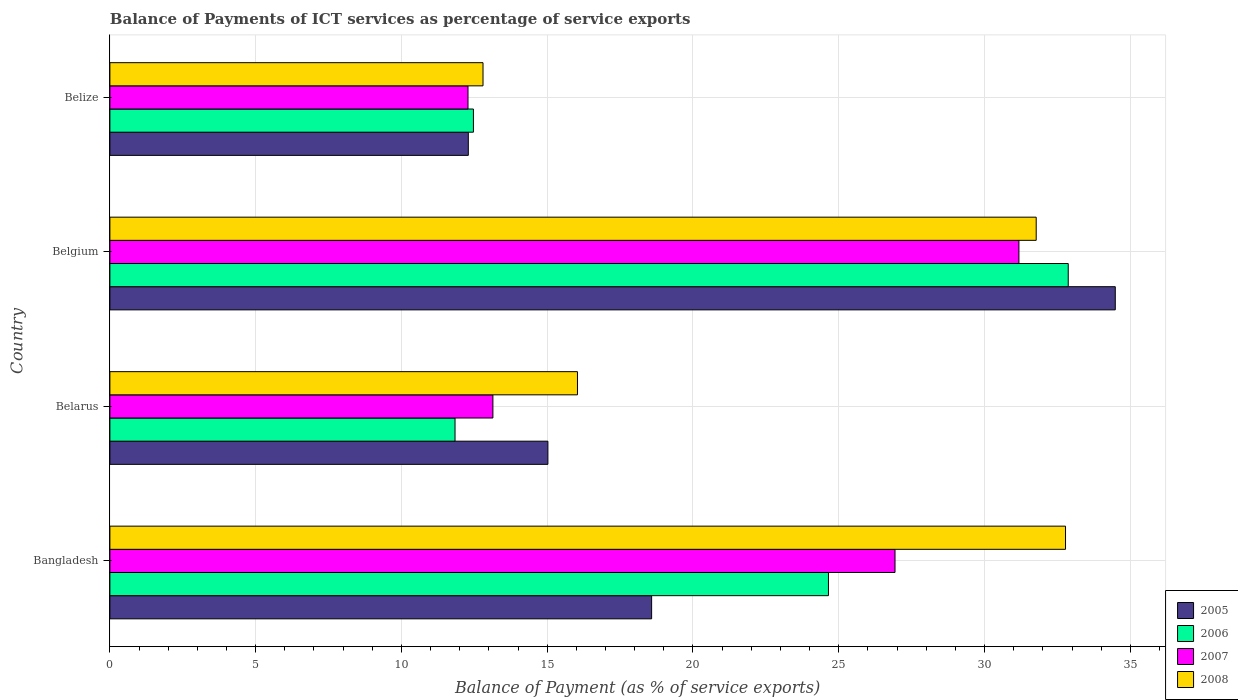How many bars are there on the 3rd tick from the top?
Your answer should be very brief. 4. What is the label of the 3rd group of bars from the top?
Offer a very short reply. Belarus. What is the balance of payments of ICT services in 2006 in Belgium?
Make the answer very short. 32.87. Across all countries, what is the maximum balance of payments of ICT services in 2008?
Keep it short and to the point. 32.78. Across all countries, what is the minimum balance of payments of ICT services in 2005?
Provide a succinct answer. 12.29. In which country was the balance of payments of ICT services in 2006 minimum?
Offer a terse response. Belarus. What is the total balance of payments of ICT services in 2006 in the graph?
Give a very brief answer. 81.83. What is the difference between the balance of payments of ICT services in 2007 in Belarus and that in Belize?
Provide a succinct answer. 0.85. What is the difference between the balance of payments of ICT services in 2005 in Bangladesh and the balance of payments of ICT services in 2008 in Belize?
Give a very brief answer. 5.78. What is the average balance of payments of ICT services in 2006 per country?
Offer a very short reply. 20.46. What is the difference between the balance of payments of ICT services in 2006 and balance of payments of ICT services in 2005 in Belarus?
Provide a succinct answer. -3.19. In how many countries, is the balance of payments of ICT services in 2007 greater than 23 %?
Provide a short and direct response. 2. What is the ratio of the balance of payments of ICT services in 2007 in Belgium to that in Belize?
Your answer should be compact. 2.54. Is the balance of payments of ICT services in 2008 in Bangladesh less than that in Belize?
Make the answer very short. No. Is the difference between the balance of payments of ICT services in 2006 in Belarus and Belgium greater than the difference between the balance of payments of ICT services in 2005 in Belarus and Belgium?
Make the answer very short. No. What is the difference between the highest and the second highest balance of payments of ICT services in 2007?
Your answer should be compact. 4.25. What is the difference between the highest and the lowest balance of payments of ICT services in 2008?
Keep it short and to the point. 19.98. Is it the case that in every country, the sum of the balance of payments of ICT services in 2005 and balance of payments of ICT services in 2008 is greater than the balance of payments of ICT services in 2007?
Your response must be concise. Yes. How many bars are there?
Make the answer very short. 16. Are the values on the major ticks of X-axis written in scientific E-notation?
Offer a very short reply. No. Does the graph contain any zero values?
Your answer should be compact. No. Where does the legend appear in the graph?
Your answer should be compact. Bottom right. How many legend labels are there?
Give a very brief answer. 4. What is the title of the graph?
Your answer should be compact. Balance of Payments of ICT services as percentage of service exports. Does "1966" appear as one of the legend labels in the graph?
Offer a very short reply. No. What is the label or title of the X-axis?
Make the answer very short. Balance of Payment (as % of service exports). What is the Balance of Payment (as % of service exports) of 2005 in Bangladesh?
Your response must be concise. 18.58. What is the Balance of Payment (as % of service exports) in 2006 in Bangladesh?
Your answer should be very brief. 24.65. What is the Balance of Payment (as % of service exports) in 2007 in Bangladesh?
Your answer should be very brief. 26.93. What is the Balance of Payment (as % of service exports) in 2008 in Bangladesh?
Ensure brevity in your answer.  32.78. What is the Balance of Payment (as % of service exports) in 2005 in Belarus?
Provide a succinct answer. 15.02. What is the Balance of Payment (as % of service exports) of 2006 in Belarus?
Your response must be concise. 11.84. What is the Balance of Payment (as % of service exports) of 2007 in Belarus?
Your answer should be very brief. 13.14. What is the Balance of Payment (as % of service exports) in 2008 in Belarus?
Ensure brevity in your answer.  16.04. What is the Balance of Payment (as % of service exports) in 2005 in Belgium?
Your response must be concise. 34.48. What is the Balance of Payment (as % of service exports) in 2006 in Belgium?
Offer a terse response. 32.87. What is the Balance of Payment (as % of service exports) of 2007 in Belgium?
Ensure brevity in your answer.  31.18. What is the Balance of Payment (as % of service exports) in 2008 in Belgium?
Provide a short and direct response. 31.77. What is the Balance of Payment (as % of service exports) of 2005 in Belize?
Your answer should be very brief. 12.29. What is the Balance of Payment (as % of service exports) in 2006 in Belize?
Provide a succinct answer. 12.47. What is the Balance of Payment (as % of service exports) in 2007 in Belize?
Ensure brevity in your answer.  12.28. What is the Balance of Payment (as % of service exports) of 2008 in Belize?
Your answer should be very brief. 12.8. Across all countries, what is the maximum Balance of Payment (as % of service exports) in 2005?
Ensure brevity in your answer.  34.48. Across all countries, what is the maximum Balance of Payment (as % of service exports) of 2006?
Give a very brief answer. 32.87. Across all countries, what is the maximum Balance of Payment (as % of service exports) in 2007?
Provide a succinct answer. 31.18. Across all countries, what is the maximum Balance of Payment (as % of service exports) in 2008?
Ensure brevity in your answer.  32.78. Across all countries, what is the minimum Balance of Payment (as % of service exports) of 2005?
Offer a terse response. 12.29. Across all countries, what is the minimum Balance of Payment (as % of service exports) in 2006?
Provide a short and direct response. 11.84. Across all countries, what is the minimum Balance of Payment (as % of service exports) of 2007?
Offer a terse response. 12.28. Across all countries, what is the minimum Balance of Payment (as % of service exports) of 2008?
Your answer should be very brief. 12.8. What is the total Balance of Payment (as % of service exports) of 2005 in the graph?
Give a very brief answer. 80.38. What is the total Balance of Payment (as % of service exports) of 2006 in the graph?
Your answer should be compact. 81.83. What is the total Balance of Payment (as % of service exports) of 2007 in the graph?
Your response must be concise. 83.53. What is the total Balance of Payment (as % of service exports) of 2008 in the graph?
Your answer should be compact. 93.39. What is the difference between the Balance of Payment (as % of service exports) of 2005 in Bangladesh and that in Belarus?
Make the answer very short. 3.56. What is the difference between the Balance of Payment (as % of service exports) in 2006 in Bangladesh and that in Belarus?
Offer a terse response. 12.81. What is the difference between the Balance of Payment (as % of service exports) in 2007 in Bangladesh and that in Belarus?
Offer a very short reply. 13.79. What is the difference between the Balance of Payment (as % of service exports) in 2008 in Bangladesh and that in Belarus?
Offer a very short reply. 16.74. What is the difference between the Balance of Payment (as % of service exports) in 2005 in Bangladesh and that in Belgium?
Your answer should be very brief. -15.9. What is the difference between the Balance of Payment (as % of service exports) of 2006 in Bangladesh and that in Belgium?
Your answer should be compact. -8.22. What is the difference between the Balance of Payment (as % of service exports) in 2007 in Bangladesh and that in Belgium?
Your response must be concise. -4.25. What is the difference between the Balance of Payment (as % of service exports) in 2008 in Bangladesh and that in Belgium?
Make the answer very short. 1.01. What is the difference between the Balance of Payment (as % of service exports) of 2005 in Bangladesh and that in Belize?
Provide a short and direct response. 6.29. What is the difference between the Balance of Payment (as % of service exports) of 2006 in Bangladesh and that in Belize?
Give a very brief answer. 12.18. What is the difference between the Balance of Payment (as % of service exports) in 2007 in Bangladesh and that in Belize?
Your answer should be compact. 14.65. What is the difference between the Balance of Payment (as % of service exports) in 2008 in Bangladesh and that in Belize?
Offer a terse response. 19.98. What is the difference between the Balance of Payment (as % of service exports) in 2005 in Belarus and that in Belgium?
Your response must be concise. -19.46. What is the difference between the Balance of Payment (as % of service exports) in 2006 in Belarus and that in Belgium?
Offer a terse response. -21.03. What is the difference between the Balance of Payment (as % of service exports) in 2007 in Belarus and that in Belgium?
Your response must be concise. -18.04. What is the difference between the Balance of Payment (as % of service exports) of 2008 in Belarus and that in Belgium?
Offer a terse response. -15.73. What is the difference between the Balance of Payment (as % of service exports) of 2005 in Belarus and that in Belize?
Your response must be concise. 2.73. What is the difference between the Balance of Payment (as % of service exports) of 2006 in Belarus and that in Belize?
Keep it short and to the point. -0.63. What is the difference between the Balance of Payment (as % of service exports) of 2007 in Belarus and that in Belize?
Keep it short and to the point. 0.85. What is the difference between the Balance of Payment (as % of service exports) in 2008 in Belarus and that in Belize?
Give a very brief answer. 3.24. What is the difference between the Balance of Payment (as % of service exports) in 2005 in Belgium and that in Belize?
Keep it short and to the point. 22.19. What is the difference between the Balance of Payment (as % of service exports) of 2006 in Belgium and that in Belize?
Provide a succinct answer. 20.4. What is the difference between the Balance of Payment (as % of service exports) of 2007 in Belgium and that in Belize?
Your response must be concise. 18.9. What is the difference between the Balance of Payment (as % of service exports) of 2008 in Belgium and that in Belize?
Give a very brief answer. 18.97. What is the difference between the Balance of Payment (as % of service exports) of 2005 in Bangladesh and the Balance of Payment (as % of service exports) of 2006 in Belarus?
Offer a very short reply. 6.74. What is the difference between the Balance of Payment (as % of service exports) of 2005 in Bangladesh and the Balance of Payment (as % of service exports) of 2007 in Belarus?
Provide a short and direct response. 5.44. What is the difference between the Balance of Payment (as % of service exports) of 2005 in Bangladesh and the Balance of Payment (as % of service exports) of 2008 in Belarus?
Give a very brief answer. 2.54. What is the difference between the Balance of Payment (as % of service exports) in 2006 in Bangladesh and the Balance of Payment (as % of service exports) in 2007 in Belarus?
Provide a short and direct response. 11.51. What is the difference between the Balance of Payment (as % of service exports) of 2006 in Bangladesh and the Balance of Payment (as % of service exports) of 2008 in Belarus?
Provide a succinct answer. 8.61. What is the difference between the Balance of Payment (as % of service exports) in 2007 in Bangladesh and the Balance of Payment (as % of service exports) in 2008 in Belarus?
Provide a succinct answer. 10.89. What is the difference between the Balance of Payment (as % of service exports) of 2005 in Bangladesh and the Balance of Payment (as % of service exports) of 2006 in Belgium?
Your answer should be very brief. -14.29. What is the difference between the Balance of Payment (as % of service exports) in 2005 in Bangladesh and the Balance of Payment (as % of service exports) in 2007 in Belgium?
Make the answer very short. -12.6. What is the difference between the Balance of Payment (as % of service exports) in 2005 in Bangladesh and the Balance of Payment (as % of service exports) in 2008 in Belgium?
Keep it short and to the point. -13.19. What is the difference between the Balance of Payment (as % of service exports) in 2006 in Bangladesh and the Balance of Payment (as % of service exports) in 2007 in Belgium?
Offer a very short reply. -6.53. What is the difference between the Balance of Payment (as % of service exports) of 2006 in Bangladesh and the Balance of Payment (as % of service exports) of 2008 in Belgium?
Your answer should be very brief. -7.13. What is the difference between the Balance of Payment (as % of service exports) in 2007 in Bangladesh and the Balance of Payment (as % of service exports) in 2008 in Belgium?
Your response must be concise. -4.84. What is the difference between the Balance of Payment (as % of service exports) of 2005 in Bangladesh and the Balance of Payment (as % of service exports) of 2006 in Belize?
Provide a succinct answer. 6.11. What is the difference between the Balance of Payment (as % of service exports) in 2005 in Bangladesh and the Balance of Payment (as % of service exports) in 2007 in Belize?
Offer a terse response. 6.3. What is the difference between the Balance of Payment (as % of service exports) of 2005 in Bangladesh and the Balance of Payment (as % of service exports) of 2008 in Belize?
Make the answer very short. 5.78. What is the difference between the Balance of Payment (as % of service exports) in 2006 in Bangladesh and the Balance of Payment (as % of service exports) in 2007 in Belize?
Offer a terse response. 12.36. What is the difference between the Balance of Payment (as % of service exports) in 2006 in Bangladesh and the Balance of Payment (as % of service exports) in 2008 in Belize?
Make the answer very short. 11.85. What is the difference between the Balance of Payment (as % of service exports) in 2007 in Bangladesh and the Balance of Payment (as % of service exports) in 2008 in Belize?
Keep it short and to the point. 14.13. What is the difference between the Balance of Payment (as % of service exports) of 2005 in Belarus and the Balance of Payment (as % of service exports) of 2006 in Belgium?
Your response must be concise. -17.85. What is the difference between the Balance of Payment (as % of service exports) of 2005 in Belarus and the Balance of Payment (as % of service exports) of 2007 in Belgium?
Your response must be concise. -16.16. What is the difference between the Balance of Payment (as % of service exports) of 2005 in Belarus and the Balance of Payment (as % of service exports) of 2008 in Belgium?
Ensure brevity in your answer.  -16.75. What is the difference between the Balance of Payment (as % of service exports) of 2006 in Belarus and the Balance of Payment (as % of service exports) of 2007 in Belgium?
Provide a short and direct response. -19.34. What is the difference between the Balance of Payment (as % of service exports) in 2006 in Belarus and the Balance of Payment (as % of service exports) in 2008 in Belgium?
Offer a very short reply. -19.93. What is the difference between the Balance of Payment (as % of service exports) of 2007 in Belarus and the Balance of Payment (as % of service exports) of 2008 in Belgium?
Offer a terse response. -18.64. What is the difference between the Balance of Payment (as % of service exports) of 2005 in Belarus and the Balance of Payment (as % of service exports) of 2006 in Belize?
Provide a short and direct response. 2.55. What is the difference between the Balance of Payment (as % of service exports) of 2005 in Belarus and the Balance of Payment (as % of service exports) of 2007 in Belize?
Provide a short and direct response. 2.74. What is the difference between the Balance of Payment (as % of service exports) of 2005 in Belarus and the Balance of Payment (as % of service exports) of 2008 in Belize?
Provide a succinct answer. 2.23. What is the difference between the Balance of Payment (as % of service exports) of 2006 in Belarus and the Balance of Payment (as % of service exports) of 2007 in Belize?
Ensure brevity in your answer.  -0.44. What is the difference between the Balance of Payment (as % of service exports) of 2006 in Belarus and the Balance of Payment (as % of service exports) of 2008 in Belize?
Offer a terse response. -0.96. What is the difference between the Balance of Payment (as % of service exports) in 2007 in Belarus and the Balance of Payment (as % of service exports) in 2008 in Belize?
Your answer should be compact. 0.34. What is the difference between the Balance of Payment (as % of service exports) of 2005 in Belgium and the Balance of Payment (as % of service exports) of 2006 in Belize?
Provide a short and direct response. 22.02. What is the difference between the Balance of Payment (as % of service exports) in 2005 in Belgium and the Balance of Payment (as % of service exports) in 2007 in Belize?
Provide a short and direct response. 22.2. What is the difference between the Balance of Payment (as % of service exports) in 2005 in Belgium and the Balance of Payment (as % of service exports) in 2008 in Belize?
Give a very brief answer. 21.69. What is the difference between the Balance of Payment (as % of service exports) of 2006 in Belgium and the Balance of Payment (as % of service exports) of 2007 in Belize?
Provide a succinct answer. 20.59. What is the difference between the Balance of Payment (as % of service exports) in 2006 in Belgium and the Balance of Payment (as % of service exports) in 2008 in Belize?
Provide a succinct answer. 20.07. What is the difference between the Balance of Payment (as % of service exports) of 2007 in Belgium and the Balance of Payment (as % of service exports) of 2008 in Belize?
Offer a very short reply. 18.38. What is the average Balance of Payment (as % of service exports) in 2005 per country?
Your answer should be very brief. 20.1. What is the average Balance of Payment (as % of service exports) in 2006 per country?
Ensure brevity in your answer.  20.46. What is the average Balance of Payment (as % of service exports) of 2007 per country?
Keep it short and to the point. 20.88. What is the average Balance of Payment (as % of service exports) in 2008 per country?
Your answer should be compact. 23.35. What is the difference between the Balance of Payment (as % of service exports) of 2005 and Balance of Payment (as % of service exports) of 2006 in Bangladesh?
Ensure brevity in your answer.  -6.07. What is the difference between the Balance of Payment (as % of service exports) of 2005 and Balance of Payment (as % of service exports) of 2007 in Bangladesh?
Your answer should be compact. -8.35. What is the difference between the Balance of Payment (as % of service exports) in 2005 and Balance of Payment (as % of service exports) in 2008 in Bangladesh?
Give a very brief answer. -14.2. What is the difference between the Balance of Payment (as % of service exports) in 2006 and Balance of Payment (as % of service exports) in 2007 in Bangladesh?
Keep it short and to the point. -2.28. What is the difference between the Balance of Payment (as % of service exports) in 2006 and Balance of Payment (as % of service exports) in 2008 in Bangladesh?
Make the answer very short. -8.13. What is the difference between the Balance of Payment (as % of service exports) of 2007 and Balance of Payment (as % of service exports) of 2008 in Bangladesh?
Provide a succinct answer. -5.85. What is the difference between the Balance of Payment (as % of service exports) of 2005 and Balance of Payment (as % of service exports) of 2006 in Belarus?
Provide a succinct answer. 3.19. What is the difference between the Balance of Payment (as % of service exports) in 2005 and Balance of Payment (as % of service exports) in 2007 in Belarus?
Your answer should be very brief. 1.89. What is the difference between the Balance of Payment (as % of service exports) of 2005 and Balance of Payment (as % of service exports) of 2008 in Belarus?
Give a very brief answer. -1.01. What is the difference between the Balance of Payment (as % of service exports) in 2006 and Balance of Payment (as % of service exports) in 2007 in Belarus?
Provide a short and direct response. -1.3. What is the difference between the Balance of Payment (as % of service exports) of 2006 and Balance of Payment (as % of service exports) of 2008 in Belarus?
Keep it short and to the point. -4.2. What is the difference between the Balance of Payment (as % of service exports) in 2007 and Balance of Payment (as % of service exports) in 2008 in Belarus?
Provide a succinct answer. -2.9. What is the difference between the Balance of Payment (as % of service exports) in 2005 and Balance of Payment (as % of service exports) in 2006 in Belgium?
Offer a very short reply. 1.61. What is the difference between the Balance of Payment (as % of service exports) of 2005 and Balance of Payment (as % of service exports) of 2007 in Belgium?
Ensure brevity in your answer.  3.31. What is the difference between the Balance of Payment (as % of service exports) of 2005 and Balance of Payment (as % of service exports) of 2008 in Belgium?
Your answer should be very brief. 2.71. What is the difference between the Balance of Payment (as % of service exports) of 2006 and Balance of Payment (as % of service exports) of 2007 in Belgium?
Provide a succinct answer. 1.69. What is the difference between the Balance of Payment (as % of service exports) in 2006 and Balance of Payment (as % of service exports) in 2008 in Belgium?
Provide a short and direct response. 1.1. What is the difference between the Balance of Payment (as % of service exports) of 2007 and Balance of Payment (as % of service exports) of 2008 in Belgium?
Ensure brevity in your answer.  -0.59. What is the difference between the Balance of Payment (as % of service exports) in 2005 and Balance of Payment (as % of service exports) in 2006 in Belize?
Give a very brief answer. -0.18. What is the difference between the Balance of Payment (as % of service exports) in 2005 and Balance of Payment (as % of service exports) in 2007 in Belize?
Your answer should be very brief. 0.01. What is the difference between the Balance of Payment (as % of service exports) in 2005 and Balance of Payment (as % of service exports) in 2008 in Belize?
Your answer should be very brief. -0.5. What is the difference between the Balance of Payment (as % of service exports) of 2006 and Balance of Payment (as % of service exports) of 2007 in Belize?
Ensure brevity in your answer.  0.19. What is the difference between the Balance of Payment (as % of service exports) of 2006 and Balance of Payment (as % of service exports) of 2008 in Belize?
Provide a short and direct response. -0.33. What is the difference between the Balance of Payment (as % of service exports) in 2007 and Balance of Payment (as % of service exports) in 2008 in Belize?
Ensure brevity in your answer.  -0.52. What is the ratio of the Balance of Payment (as % of service exports) of 2005 in Bangladesh to that in Belarus?
Make the answer very short. 1.24. What is the ratio of the Balance of Payment (as % of service exports) of 2006 in Bangladesh to that in Belarus?
Keep it short and to the point. 2.08. What is the ratio of the Balance of Payment (as % of service exports) of 2007 in Bangladesh to that in Belarus?
Ensure brevity in your answer.  2.05. What is the ratio of the Balance of Payment (as % of service exports) in 2008 in Bangladesh to that in Belarus?
Keep it short and to the point. 2.04. What is the ratio of the Balance of Payment (as % of service exports) in 2005 in Bangladesh to that in Belgium?
Keep it short and to the point. 0.54. What is the ratio of the Balance of Payment (as % of service exports) of 2006 in Bangladesh to that in Belgium?
Your answer should be compact. 0.75. What is the ratio of the Balance of Payment (as % of service exports) of 2007 in Bangladesh to that in Belgium?
Your answer should be compact. 0.86. What is the ratio of the Balance of Payment (as % of service exports) of 2008 in Bangladesh to that in Belgium?
Keep it short and to the point. 1.03. What is the ratio of the Balance of Payment (as % of service exports) in 2005 in Bangladesh to that in Belize?
Offer a terse response. 1.51. What is the ratio of the Balance of Payment (as % of service exports) of 2006 in Bangladesh to that in Belize?
Your answer should be compact. 1.98. What is the ratio of the Balance of Payment (as % of service exports) of 2007 in Bangladesh to that in Belize?
Provide a short and direct response. 2.19. What is the ratio of the Balance of Payment (as % of service exports) of 2008 in Bangladesh to that in Belize?
Provide a short and direct response. 2.56. What is the ratio of the Balance of Payment (as % of service exports) of 2005 in Belarus to that in Belgium?
Your answer should be compact. 0.44. What is the ratio of the Balance of Payment (as % of service exports) of 2006 in Belarus to that in Belgium?
Your answer should be compact. 0.36. What is the ratio of the Balance of Payment (as % of service exports) in 2007 in Belarus to that in Belgium?
Keep it short and to the point. 0.42. What is the ratio of the Balance of Payment (as % of service exports) of 2008 in Belarus to that in Belgium?
Offer a very short reply. 0.5. What is the ratio of the Balance of Payment (as % of service exports) in 2005 in Belarus to that in Belize?
Make the answer very short. 1.22. What is the ratio of the Balance of Payment (as % of service exports) of 2006 in Belarus to that in Belize?
Ensure brevity in your answer.  0.95. What is the ratio of the Balance of Payment (as % of service exports) of 2007 in Belarus to that in Belize?
Your answer should be very brief. 1.07. What is the ratio of the Balance of Payment (as % of service exports) in 2008 in Belarus to that in Belize?
Make the answer very short. 1.25. What is the ratio of the Balance of Payment (as % of service exports) of 2005 in Belgium to that in Belize?
Your response must be concise. 2.81. What is the ratio of the Balance of Payment (as % of service exports) in 2006 in Belgium to that in Belize?
Your answer should be very brief. 2.64. What is the ratio of the Balance of Payment (as % of service exports) in 2007 in Belgium to that in Belize?
Your answer should be compact. 2.54. What is the ratio of the Balance of Payment (as % of service exports) of 2008 in Belgium to that in Belize?
Ensure brevity in your answer.  2.48. What is the difference between the highest and the second highest Balance of Payment (as % of service exports) of 2005?
Ensure brevity in your answer.  15.9. What is the difference between the highest and the second highest Balance of Payment (as % of service exports) of 2006?
Offer a terse response. 8.22. What is the difference between the highest and the second highest Balance of Payment (as % of service exports) of 2007?
Ensure brevity in your answer.  4.25. What is the difference between the highest and the second highest Balance of Payment (as % of service exports) of 2008?
Give a very brief answer. 1.01. What is the difference between the highest and the lowest Balance of Payment (as % of service exports) of 2005?
Give a very brief answer. 22.19. What is the difference between the highest and the lowest Balance of Payment (as % of service exports) in 2006?
Offer a terse response. 21.03. What is the difference between the highest and the lowest Balance of Payment (as % of service exports) of 2007?
Your response must be concise. 18.9. What is the difference between the highest and the lowest Balance of Payment (as % of service exports) of 2008?
Offer a terse response. 19.98. 